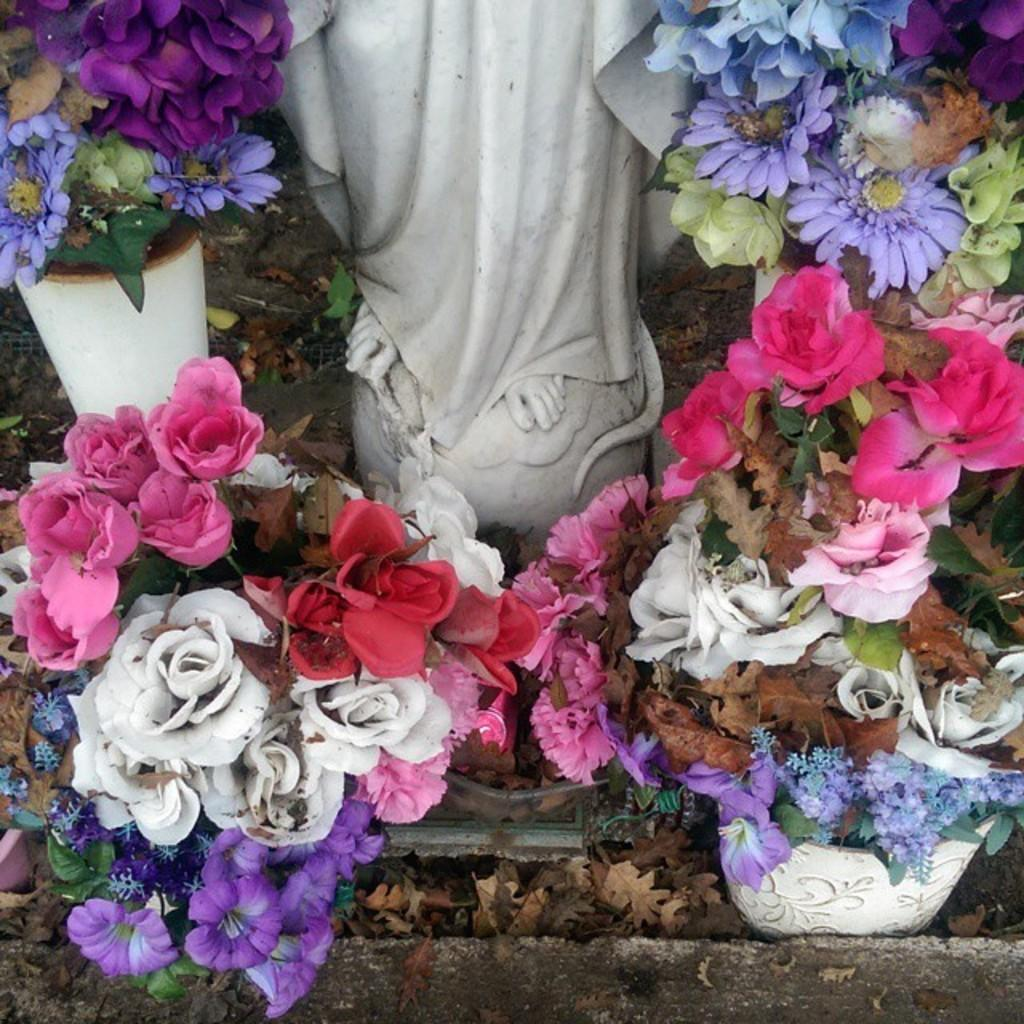What type of objects can be seen in the image? There are flower pots and sculptures visible in the image. What is growing in the flower pots? Flowers are visible in the image. Can you describe the sculptures in the image? Unfortunately, the facts provided do not give a detailed description of the sculptures. What type of power is being generated by the flowers in the image? The flowers in the image are not generating any power; they are simply growing in the flower pots. 